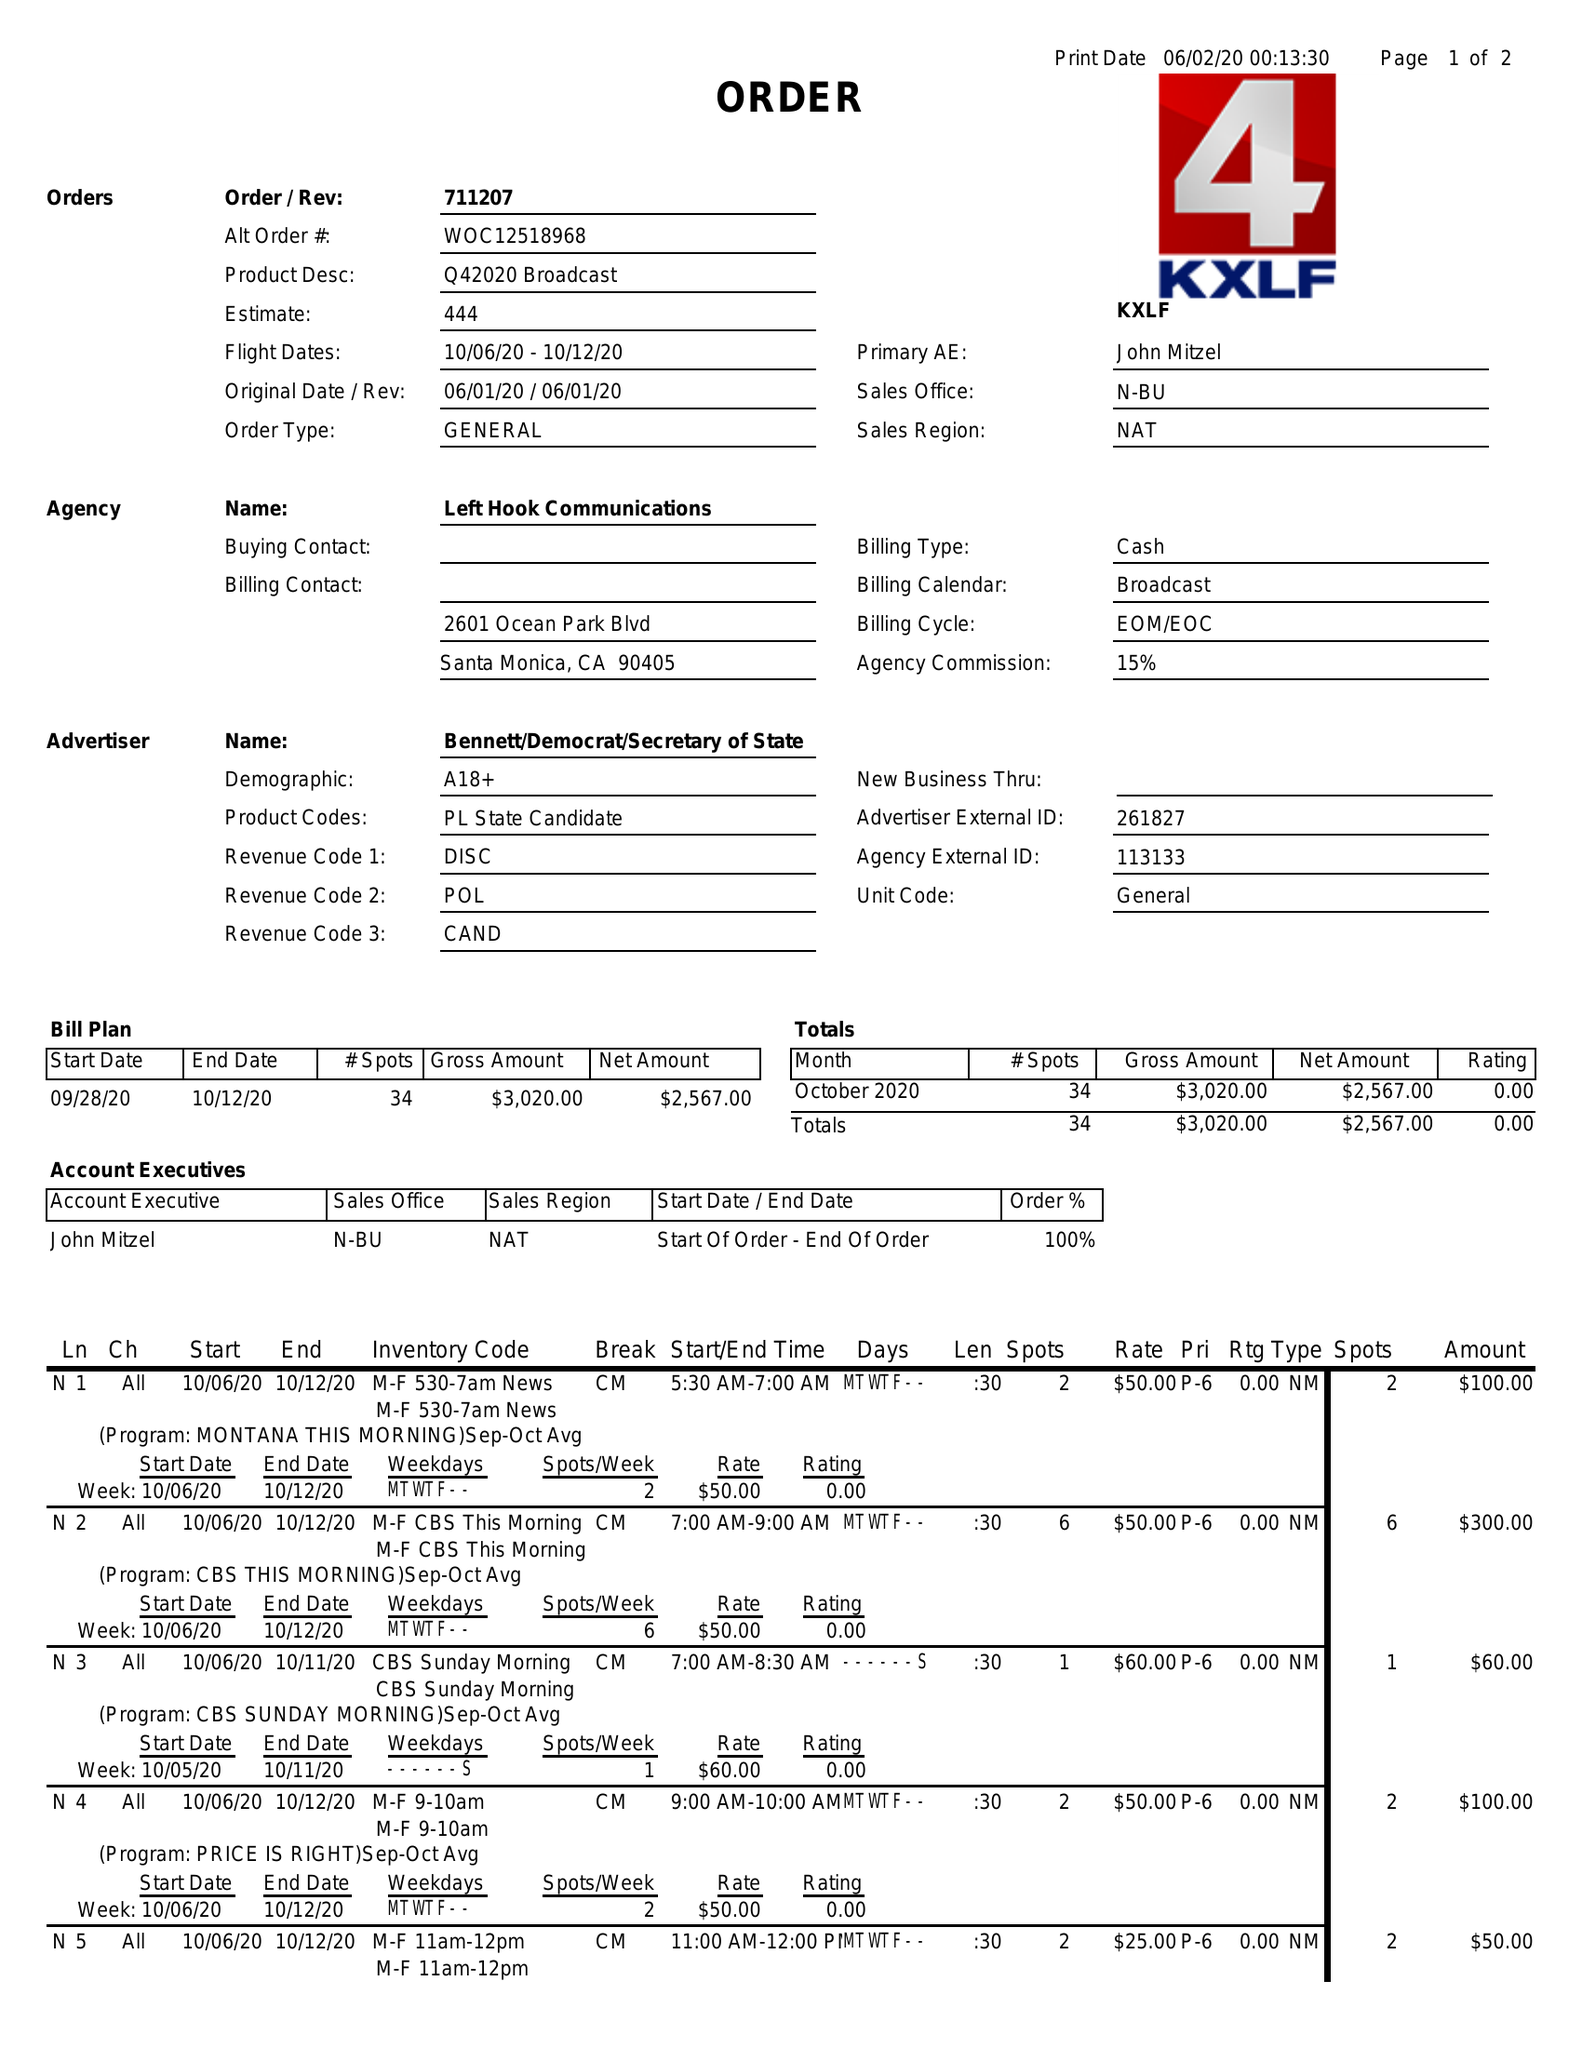What is the value for the flight_to?
Answer the question using a single word or phrase. 10/12/20 